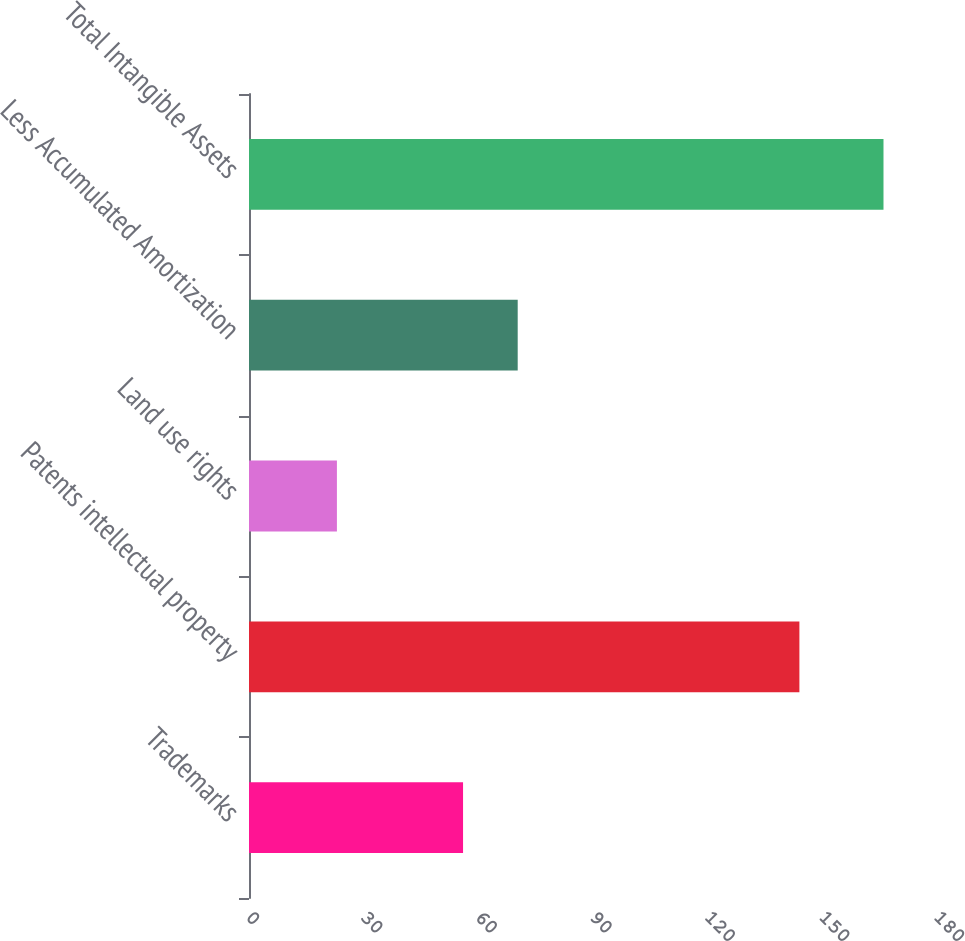<chart> <loc_0><loc_0><loc_500><loc_500><bar_chart><fcel>Trademarks<fcel>Patents intellectual property<fcel>Land use rights<fcel>Less Accumulated Amortization<fcel>Total Intangible Assets<nl><fcel>56<fcel>144<fcel>23<fcel>70.3<fcel>166<nl></chart> 